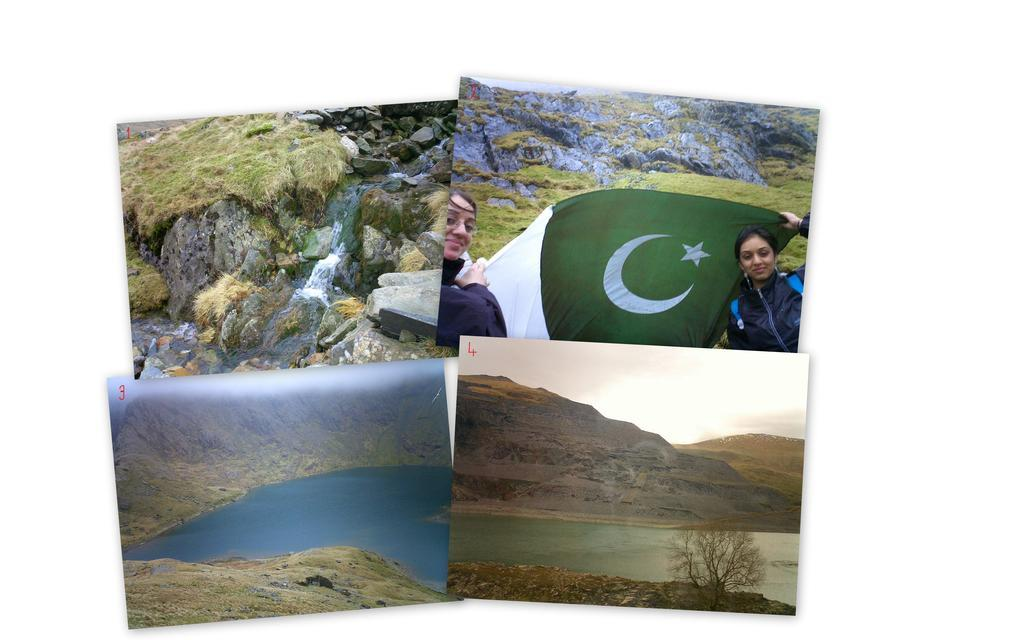What type of artwork is the image? The image is a collage. What natural feature can be seen in the collage? There is a waterfall in the collage. What type of geological formations are present in the collage? There are stones and rocks in the collage. What human element is present in the collage? There is a woman holding a flag in the collage. What type of landforms can be seen in the collage? There are hills in the collage. What bodies of water are present in the collage? There are lakes in the collage. What type of vegetation is present in the collage? There are trees in the collage. What type of care can be seen being provided to the thumb in the image? There is no thumb present in the image, so no care can be observed. 